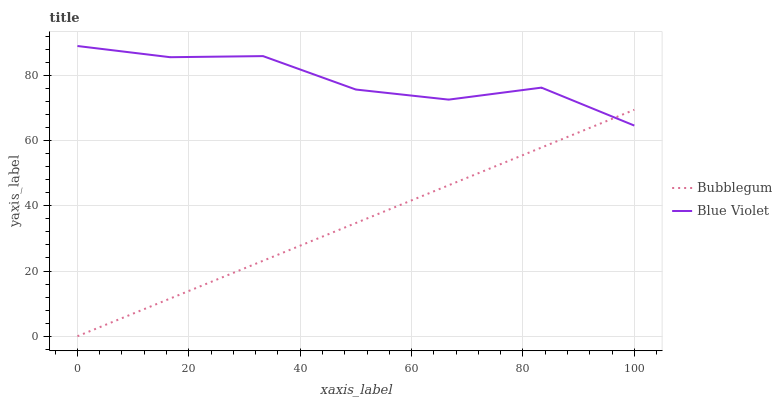Does Bubblegum have the minimum area under the curve?
Answer yes or no. Yes. Does Blue Violet have the maximum area under the curve?
Answer yes or no. Yes. Does Bubblegum have the maximum area under the curve?
Answer yes or no. No. Is Bubblegum the smoothest?
Answer yes or no. Yes. Is Blue Violet the roughest?
Answer yes or no. Yes. Is Bubblegum the roughest?
Answer yes or no. No. Does Bubblegum have the lowest value?
Answer yes or no. Yes. Does Blue Violet have the highest value?
Answer yes or no. Yes. Does Bubblegum have the highest value?
Answer yes or no. No. Does Blue Violet intersect Bubblegum?
Answer yes or no. Yes. Is Blue Violet less than Bubblegum?
Answer yes or no. No. Is Blue Violet greater than Bubblegum?
Answer yes or no. No. 